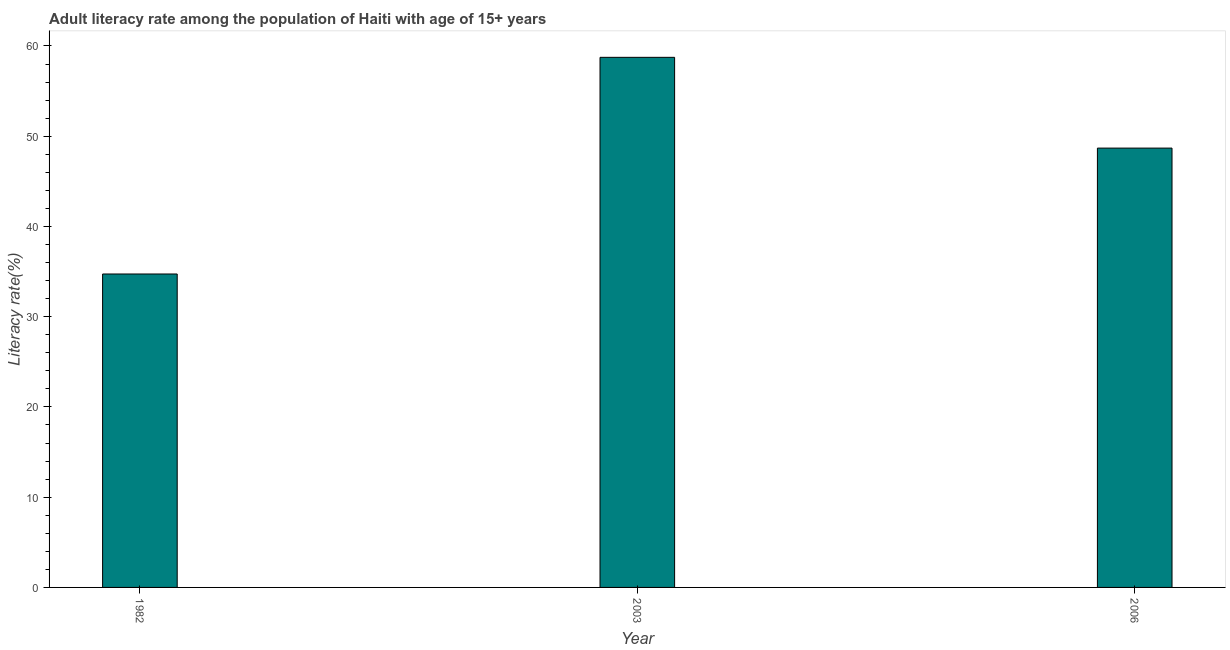What is the title of the graph?
Your response must be concise. Adult literacy rate among the population of Haiti with age of 15+ years. What is the label or title of the Y-axis?
Your response must be concise. Literacy rate(%). What is the adult literacy rate in 2003?
Offer a very short reply. 58.74. Across all years, what is the maximum adult literacy rate?
Ensure brevity in your answer.  58.74. Across all years, what is the minimum adult literacy rate?
Make the answer very short. 34.73. What is the sum of the adult literacy rate?
Offer a terse response. 142.16. What is the difference between the adult literacy rate in 1982 and 2006?
Offer a very short reply. -13.95. What is the average adult literacy rate per year?
Make the answer very short. 47.39. What is the median adult literacy rate?
Give a very brief answer. 48.69. Do a majority of the years between 2003 and 1982 (inclusive) have adult literacy rate greater than 50 %?
Make the answer very short. No. What is the ratio of the adult literacy rate in 1982 to that in 2006?
Give a very brief answer. 0.71. Is the adult literacy rate in 2003 less than that in 2006?
Offer a terse response. No. Is the difference between the adult literacy rate in 1982 and 2006 greater than the difference between any two years?
Your answer should be compact. No. What is the difference between the highest and the second highest adult literacy rate?
Provide a short and direct response. 10.06. What is the difference between the highest and the lowest adult literacy rate?
Offer a very short reply. 24.01. How many years are there in the graph?
Give a very brief answer. 3. What is the difference between two consecutive major ticks on the Y-axis?
Offer a terse response. 10. What is the Literacy rate(%) in 1982?
Your answer should be compact. 34.73. What is the Literacy rate(%) of 2003?
Your answer should be very brief. 58.74. What is the Literacy rate(%) of 2006?
Your answer should be compact. 48.69. What is the difference between the Literacy rate(%) in 1982 and 2003?
Provide a succinct answer. -24.01. What is the difference between the Literacy rate(%) in 1982 and 2006?
Your answer should be compact. -13.95. What is the difference between the Literacy rate(%) in 2003 and 2006?
Provide a short and direct response. 10.06. What is the ratio of the Literacy rate(%) in 1982 to that in 2003?
Offer a very short reply. 0.59. What is the ratio of the Literacy rate(%) in 1982 to that in 2006?
Ensure brevity in your answer.  0.71. What is the ratio of the Literacy rate(%) in 2003 to that in 2006?
Keep it short and to the point. 1.21. 